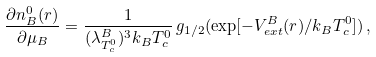Convert formula to latex. <formula><loc_0><loc_0><loc_500><loc_500>\frac { \partial n _ { B } ^ { 0 } ( { r } ) } { \partial \mu _ { B } } = \frac { 1 } { ( \lambda _ { T _ { c } ^ { 0 } } ^ { B } ) ^ { 3 } k _ { B } T _ { c } ^ { 0 } } \, g _ { 1 / 2 } ( \exp [ - V _ { e x t } ^ { B } ( { r } ) / k _ { B } T _ { c } ^ { 0 } ] ) \, ,</formula> 